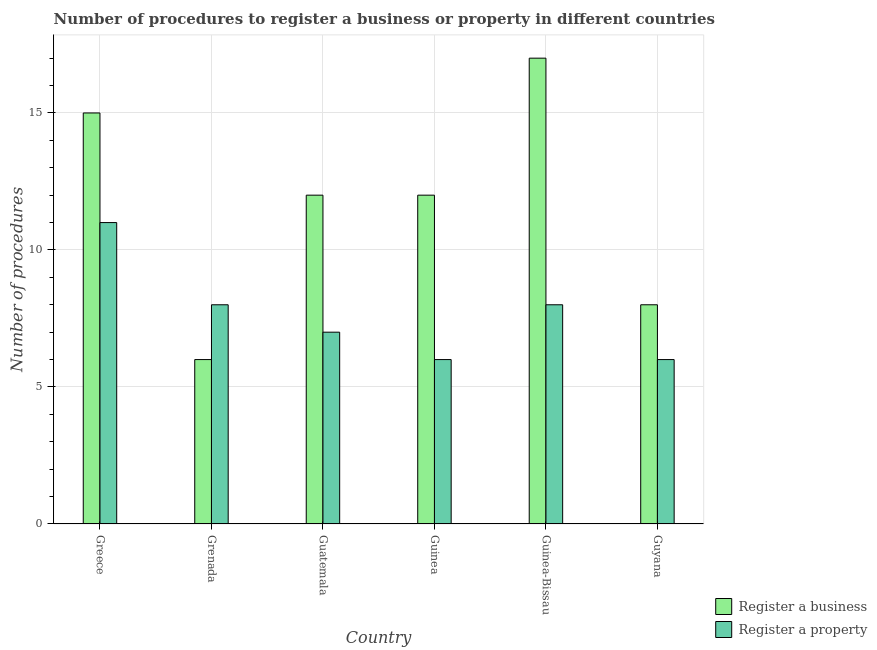Are the number of bars per tick equal to the number of legend labels?
Provide a succinct answer. Yes. Are the number of bars on each tick of the X-axis equal?
Offer a very short reply. Yes. How many bars are there on the 6th tick from the right?
Give a very brief answer. 2. What is the label of the 5th group of bars from the left?
Ensure brevity in your answer.  Guinea-Bissau. In how many cases, is the number of bars for a given country not equal to the number of legend labels?
Make the answer very short. 0. What is the number of procedures to register a business in Greece?
Your answer should be very brief. 15. In which country was the number of procedures to register a business maximum?
Ensure brevity in your answer.  Guinea-Bissau. In which country was the number of procedures to register a property minimum?
Offer a very short reply. Guinea. What is the total number of procedures to register a business in the graph?
Your response must be concise. 70. What is the difference between the number of procedures to register a property in Grenada and that in Guinea-Bissau?
Offer a very short reply. 0. What is the difference between the number of procedures to register a business in Guyana and the number of procedures to register a property in Guatemala?
Your answer should be very brief. 1. What is the average number of procedures to register a property per country?
Your response must be concise. 7.67. What is the difference between the number of procedures to register a property and number of procedures to register a business in Guyana?
Make the answer very short. -2. In how many countries, is the number of procedures to register a property greater than 15 ?
Your answer should be very brief. 0. What is the ratio of the number of procedures to register a property in Greece to that in Guatemala?
Make the answer very short. 1.57. What is the difference between the highest and the second highest number of procedures to register a property?
Your answer should be compact. 3. What is the difference between the highest and the lowest number of procedures to register a business?
Offer a terse response. 11. In how many countries, is the number of procedures to register a property greater than the average number of procedures to register a property taken over all countries?
Keep it short and to the point. 3. What does the 1st bar from the left in Guinea represents?
Your answer should be compact. Register a business. What does the 2nd bar from the right in Greece represents?
Your response must be concise. Register a business. How many bars are there?
Provide a short and direct response. 12. How many legend labels are there?
Give a very brief answer. 2. What is the title of the graph?
Offer a very short reply. Number of procedures to register a business or property in different countries. What is the label or title of the Y-axis?
Keep it short and to the point. Number of procedures. What is the Number of procedures of Register a business in Greece?
Your answer should be compact. 15. What is the Number of procedures of Register a business in Guatemala?
Offer a terse response. 12. What is the Number of procedures in Register a property in Guatemala?
Offer a very short reply. 7. What is the Number of procedures in Register a business in Guinea?
Provide a short and direct response. 12. What is the Number of procedures of Register a property in Guinea-Bissau?
Offer a terse response. 8. What is the Number of procedures of Register a business in Guyana?
Make the answer very short. 8. Across all countries, what is the minimum Number of procedures of Register a property?
Provide a short and direct response. 6. What is the difference between the Number of procedures in Register a property in Greece and that in Grenada?
Provide a short and direct response. 3. What is the difference between the Number of procedures of Register a business in Greece and that in Guyana?
Offer a terse response. 7. What is the difference between the Number of procedures of Register a business in Grenada and that in Guatemala?
Give a very brief answer. -6. What is the difference between the Number of procedures of Register a property in Grenada and that in Guatemala?
Provide a succinct answer. 1. What is the difference between the Number of procedures of Register a business in Grenada and that in Guinea?
Make the answer very short. -6. What is the difference between the Number of procedures of Register a property in Grenada and that in Guinea?
Offer a very short reply. 2. What is the difference between the Number of procedures in Register a business in Grenada and that in Guinea-Bissau?
Your answer should be very brief. -11. What is the difference between the Number of procedures in Register a property in Grenada and that in Guinea-Bissau?
Your answer should be very brief. 0. What is the difference between the Number of procedures in Register a business in Grenada and that in Guyana?
Your answer should be compact. -2. What is the difference between the Number of procedures in Register a business in Guatemala and that in Guinea?
Offer a very short reply. 0. What is the difference between the Number of procedures of Register a property in Guatemala and that in Guinea?
Offer a terse response. 1. What is the difference between the Number of procedures of Register a property in Guatemala and that in Guinea-Bissau?
Keep it short and to the point. -1. What is the difference between the Number of procedures in Register a business in Guatemala and that in Guyana?
Offer a terse response. 4. What is the difference between the Number of procedures of Register a property in Guatemala and that in Guyana?
Provide a short and direct response. 1. What is the difference between the Number of procedures of Register a business in Guinea and that in Guinea-Bissau?
Provide a short and direct response. -5. What is the difference between the Number of procedures in Register a property in Guinea and that in Guinea-Bissau?
Your answer should be compact. -2. What is the difference between the Number of procedures in Register a business in Guinea-Bissau and that in Guyana?
Give a very brief answer. 9. What is the difference between the Number of procedures of Register a property in Guinea-Bissau and that in Guyana?
Ensure brevity in your answer.  2. What is the difference between the Number of procedures in Register a business in Greece and the Number of procedures in Register a property in Grenada?
Offer a very short reply. 7. What is the difference between the Number of procedures in Register a business in Greece and the Number of procedures in Register a property in Guyana?
Keep it short and to the point. 9. What is the difference between the Number of procedures in Register a business in Grenada and the Number of procedures in Register a property in Guinea?
Keep it short and to the point. 0. What is the difference between the Number of procedures in Register a business in Grenada and the Number of procedures in Register a property in Guyana?
Offer a terse response. 0. What is the difference between the Number of procedures of Register a business in Guatemala and the Number of procedures of Register a property in Guinea?
Provide a short and direct response. 6. What is the difference between the Number of procedures in Register a business in Guatemala and the Number of procedures in Register a property in Guinea-Bissau?
Make the answer very short. 4. What is the difference between the Number of procedures of Register a business in Guinea and the Number of procedures of Register a property in Guinea-Bissau?
Ensure brevity in your answer.  4. What is the difference between the Number of procedures in Register a business in Guinea and the Number of procedures in Register a property in Guyana?
Your response must be concise. 6. What is the difference between the Number of procedures in Register a business in Guinea-Bissau and the Number of procedures in Register a property in Guyana?
Your answer should be compact. 11. What is the average Number of procedures in Register a business per country?
Give a very brief answer. 11.67. What is the average Number of procedures in Register a property per country?
Your response must be concise. 7.67. What is the difference between the Number of procedures of Register a business and Number of procedures of Register a property in Guatemala?
Offer a very short reply. 5. What is the ratio of the Number of procedures of Register a property in Greece to that in Grenada?
Your answer should be very brief. 1.38. What is the ratio of the Number of procedures of Register a business in Greece to that in Guatemala?
Provide a short and direct response. 1.25. What is the ratio of the Number of procedures of Register a property in Greece to that in Guatemala?
Your answer should be very brief. 1.57. What is the ratio of the Number of procedures in Register a business in Greece to that in Guinea?
Ensure brevity in your answer.  1.25. What is the ratio of the Number of procedures of Register a property in Greece to that in Guinea?
Your answer should be compact. 1.83. What is the ratio of the Number of procedures in Register a business in Greece to that in Guinea-Bissau?
Your answer should be very brief. 0.88. What is the ratio of the Number of procedures of Register a property in Greece to that in Guinea-Bissau?
Provide a succinct answer. 1.38. What is the ratio of the Number of procedures of Register a business in Greece to that in Guyana?
Your answer should be compact. 1.88. What is the ratio of the Number of procedures of Register a property in Greece to that in Guyana?
Your response must be concise. 1.83. What is the ratio of the Number of procedures in Register a property in Grenada to that in Guatemala?
Keep it short and to the point. 1.14. What is the ratio of the Number of procedures of Register a business in Grenada to that in Guinea?
Provide a succinct answer. 0.5. What is the ratio of the Number of procedures of Register a property in Grenada to that in Guinea?
Your response must be concise. 1.33. What is the ratio of the Number of procedures of Register a business in Grenada to that in Guinea-Bissau?
Your answer should be compact. 0.35. What is the ratio of the Number of procedures of Register a property in Grenada to that in Guinea-Bissau?
Provide a short and direct response. 1. What is the ratio of the Number of procedures of Register a property in Grenada to that in Guyana?
Provide a short and direct response. 1.33. What is the ratio of the Number of procedures in Register a property in Guatemala to that in Guinea?
Your answer should be compact. 1.17. What is the ratio of the Number of procedures of Register a business in Guatemala to that in Guinea-Bissau?
Offer a very short reply. 0.71. What is the ratio of the Number of procedures in Register a business in Guinea to that in Guinea-Bissau?
Offer a very short reply. 0.71. What is the ratio of the Number of procedures of Register a property in Guinea to that in Guinea-Bissau?
Keep it short and to the point. 0.75. What is the ratio of the Number of procedures of Register a property in Guinea to that in Guyana?
Provide a short and direct response. 1. What is the ratio of the Number of procedures in Register a business in Guinea-Bissau to that in Guyana?
Keep it short and to the point. 2.12. What is the ratio of the Number of procedures of Register a property in Guinea-Bissau to that in Guyana?
Give a very brief answer. 1.33. What is the difference between the highest and the lowest Number of procedures in Register a business?
Your answer should be compact. 11. What is the difference between the highest and the lowest Number of procedures in Register a property?
Your answer should be compact. 5. 